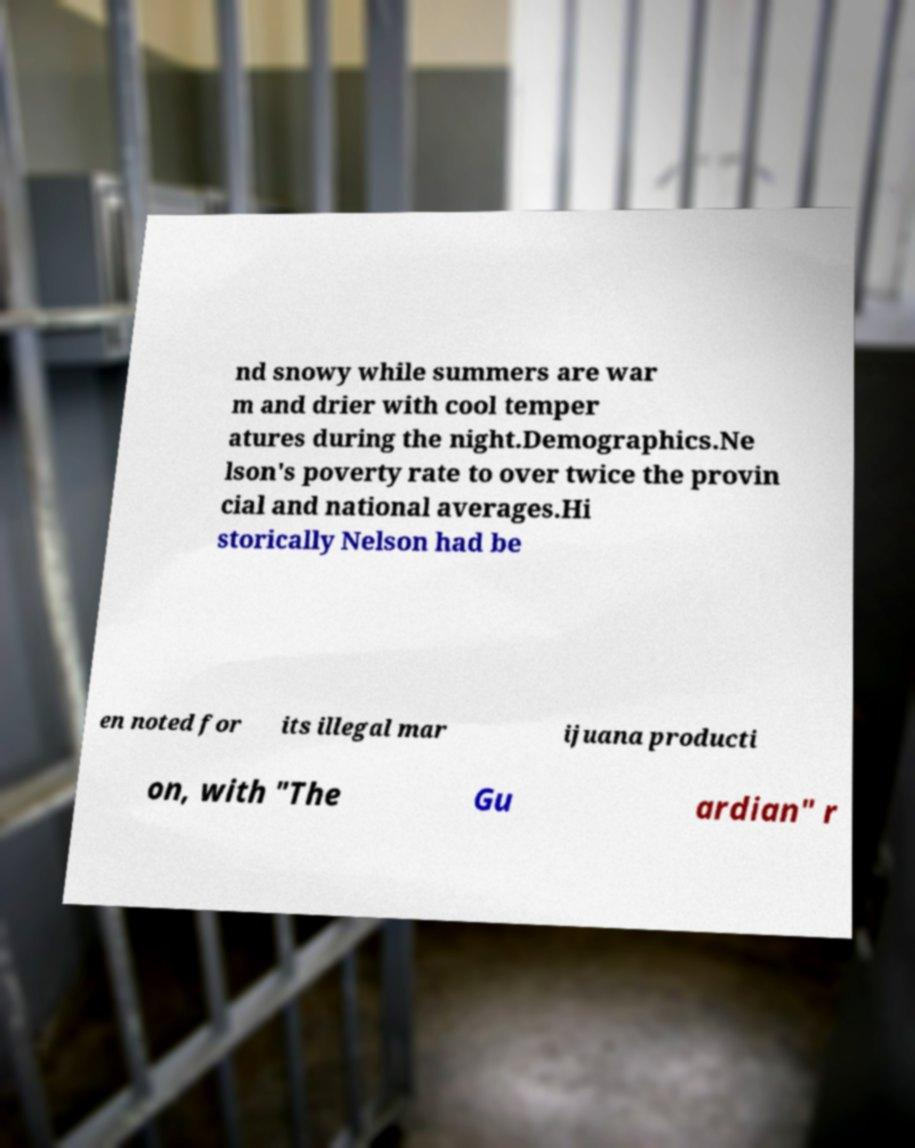Can you read and provide the text displayed in the image?This photo seems to have some interesting text. Can you extract and type it out for me? nd snowy while summers are war m and drier with cool temper atures during the night.Demographics.Ne lson's poverty rate to over twice the provin cial and national averages.Hi storically Nelson had be en noted for its illegal mar ijuana producti on, with "The Gu ardian" r 